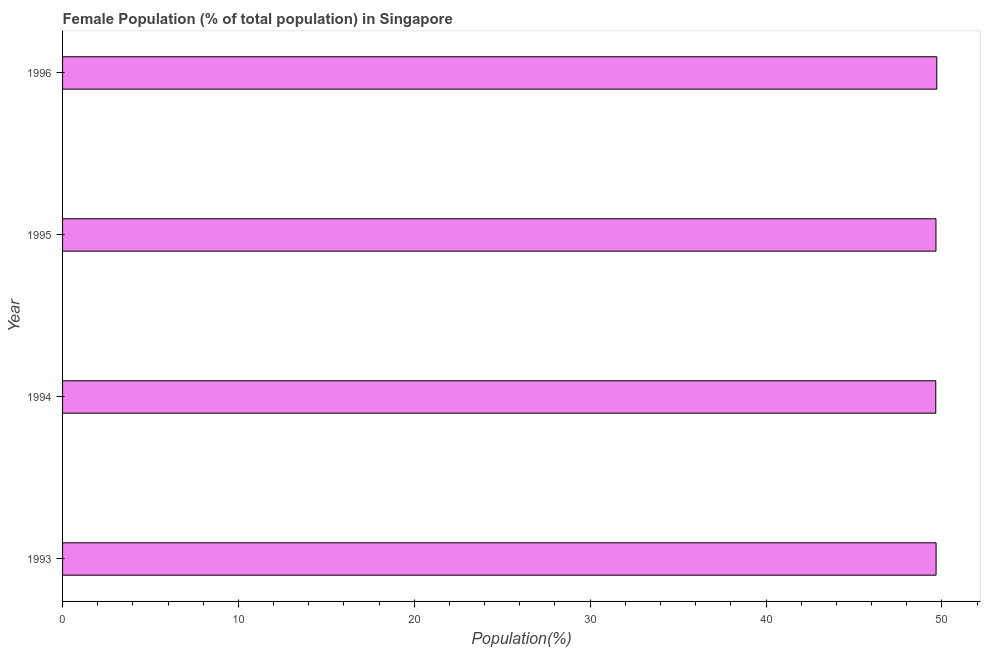What is the title of the graph?
Your answer should be very brief. Female Population (% of total population) in Singapore. What is the label or title of the X-axis?
Ensure brevity in your answer.  Population(%). What is the label or title of the Y-axis?
Make the answer very short. Year. What is the female population in 1994?
Provide a succinct answer. 49.65. Across all years, what is the maximum female population?
Provide a succinct answer. 49.71. Across all years, what is the minimum female population?
Provide a succinct answer. 49.65. In which year was the female population minimum?
Provide a short and direct response. 1994. What is the sum of the female population?
Your response must be concise. 198.7. What is the difference between the female population in 1995 and 1996?
Provide a short and direct response. -0.05. What is the average female population per year?
Your answer should be very brief. 49.67. What is the median female population?
Your response must be concise. 49.67. In how many years, is the female population greater than 4 %?
Make the answer very short. 4. Do a majority of the years between 1995 and 1996 (inclusive) have female population greater than 28 %?
Keep it short and to the point. Yes. What is the ratio of the female population in 1993 to that in 1994?
Your answer should be compact. 1. Is the female population in 1993 less than that in 1994?
Provide a short and direct response. No. Is the difference between the female population in 1993 and 1996 greater than the difference between any two years?
Ensure brevity in your answer.  No. What is the difference between the highest and the second highest female population?
Ensure brevity in your answer.  0.04. In how many years, is the female population greater than the average female population taken over all years?
Your answer should be very brief. 1. How many bars are there?
Your response must be concise. 4. Are all the bars in the graph horizontal?
Make the answer very short. Yes. What is the difference between two consecutive major ticks on the X-axis?
Keep it short and to the point. 10. What is the Population(%) in 1993?
Ensure brevity in your answer.  49.67. What is the Population(%) of 1994?
Your response must be concise. 49.65. What is the Population(%) in 1995?
Make the answer very short. 49.66. What is the Population(%) of 1996?
Keep it short and to the point. 49.71. What is the difference between the Population(%) in 1993 and 1994?
Your answer should be very brief. 0.02. What is the difference between the Population(%) in 1993 and 1995?
Offer a very short reply. 0.01. What is the difference between the Population(%) in 1993 and 1996?
Your response must be concise. -0.04. What is the difference between the Population(%) in 1994 and 1995?
Your response must be concise. -0.01. What is the difference between the Population(%) in 1994 and 1996?
Offer a very short reply. -0.06. What is the difference between the Population(%) in 1995 and 1996?
Keep it short and to the point. -0.05. What is the ratio of the Population(%) in 1993 to that in 1994?
Keep it short and to the point. 1. What is the ratio of the Population(%) in 1993 to that in 1995?
Offer a very short reply. 1. 